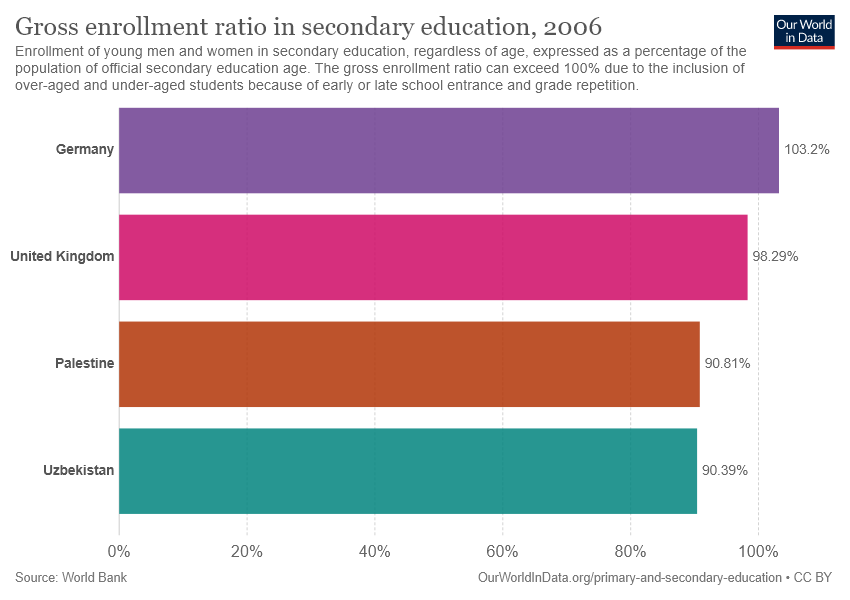Highlight a few significant elements in this photo. The median and average percentages of all bars, including [94.55, 95.67], can be found by using Python. The Gross enrollment ratio in secondary education in Germany was 1.032 in the year of the data. 